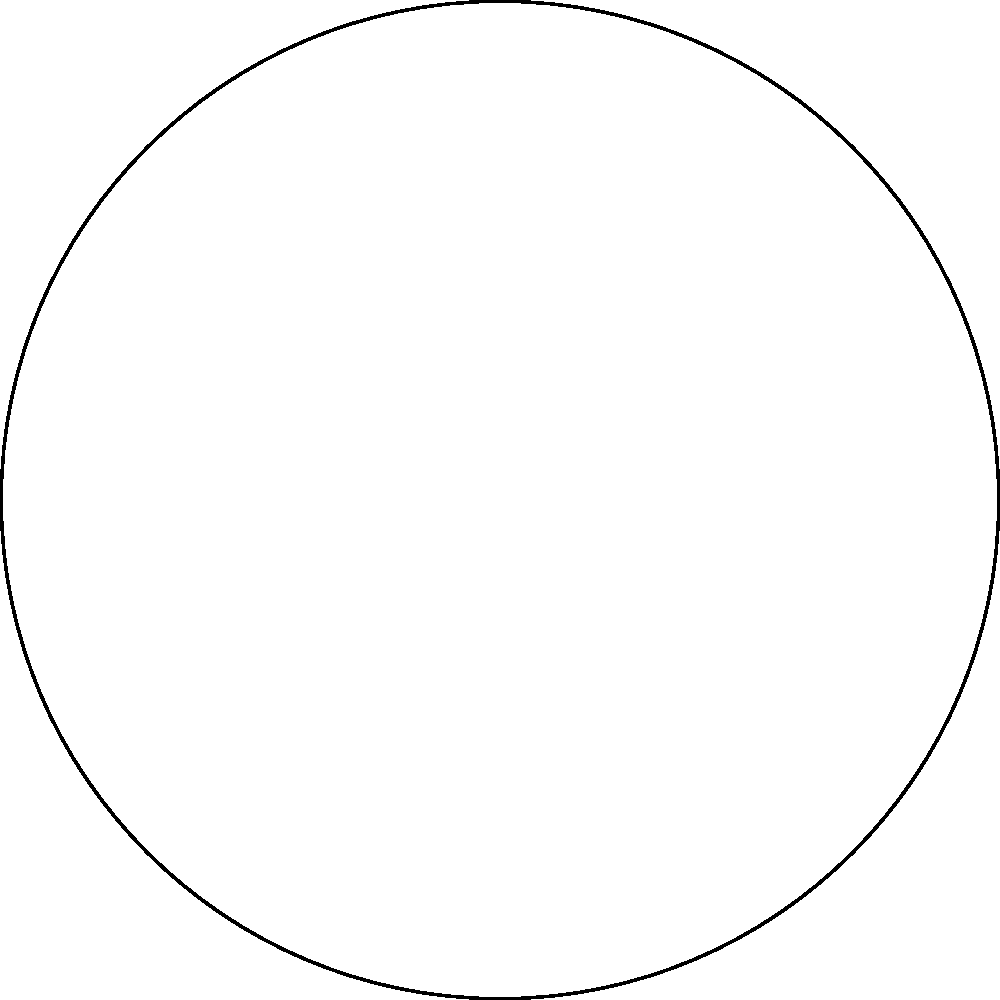As you recall from your days at sea, the steering wheel of your old fishing vessel had 8 spokes. If we consider the rotational symmetry of this wheel, which group does it represent? How many unique rotations (including the identity) are possible? Let's approach this step-by-step:

1) The steering wheel has 8 spokes, which means it has 8-fold rotational symmetry.

2) In group theory, this type of symmetry is represented by the cyclic group $C_n$, where $n$ is the number of symmetries.

3) In this case, we have $C_8$, the cyclic group of order 8.

4) The elements of $C_8$ represent the possible rotations:
   - Identity (no rotation)
   - Rotation by 45° (1/8 of a full turn)
   - Rotation by 90° (1/4 of a full turn)
   - Rotation by 135° (3/8 of a full turn)
   - Rotation by 180° (1/2 of a full turn)
   - Rotation by 225° (5/8 of a full turn)
   - Rotation by 270° (3/4 of a full turn)
   - Rotation by 315° (7/8 of a full turn)

5) Each of these rotations brings the wheel to a position that looks identical to its starting position.

6) The number of unique rotations is equal to the order of the group $C_8$, which is 8.

Therefore, the steering wheel represents the cyclic group $C_8$, and there are 8 unique rotations possible.
Answer: $C_8$, 8 rotations 